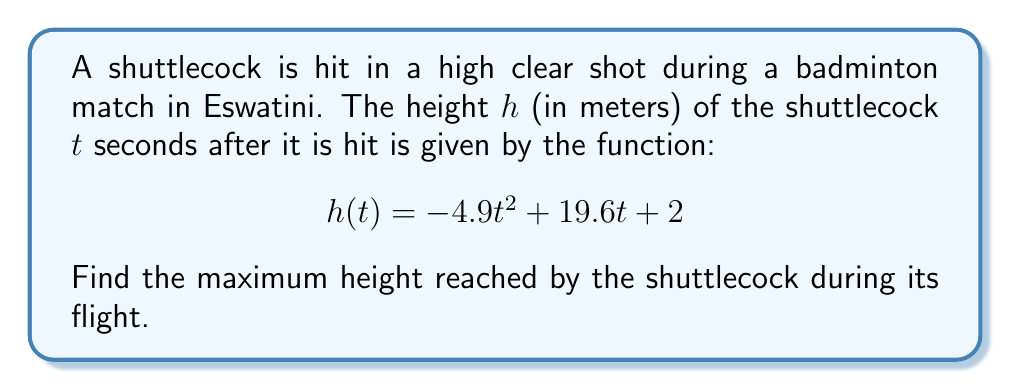Can you answer this question? To find the maximum height of the shuttlecock, we need to follow these steps:

1) The maximum height occurs at the vertex of the parabola described by h(t). To find the vertex, we need to determine when the derivative of h(t) equals zero.

2) First, let's find the derivative of h(t):
   $$h'(t) = -9.8t + 19.6$$

3) Set h'(t) = 0 and solve for t:
   $$-9.8t + 19.6 = 0$$
   $$-9.8t = -19.6$$
   $$t = 2$$

4) This value of t represents the time when the shuttlecock reaches its maximum height.

5) To find the maximum height, we substitute t = 2 into the original function h(t):

   $$h(2) = -4.9(2)^2 + 19.6(2) + 2$$
   $$= -4.9(4) + 39.2 + 2$$
   $$= -19.6 + 39.2 + 2$$
   $$= 21.6$$

Therefore, the maximum height reached by the shuttlecock is 21.6 meters.
Answer: 21.6 meters 